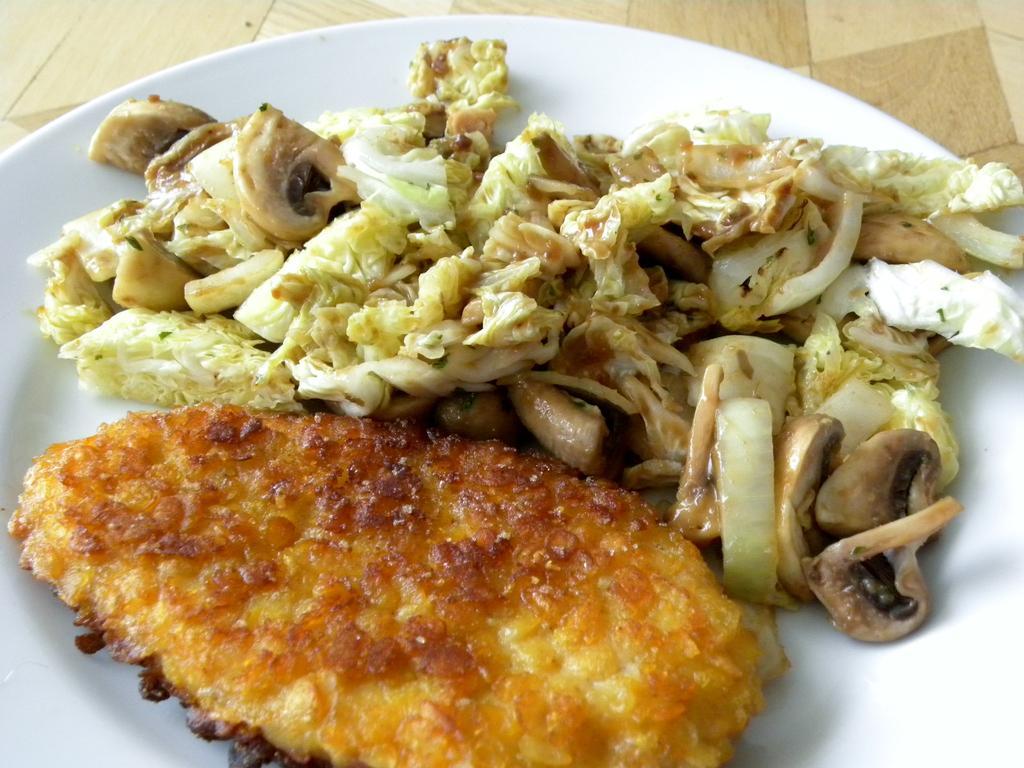How would you summarize this image in a sentence or two? There is a white plate on a surface. On the plate there are some food item. 